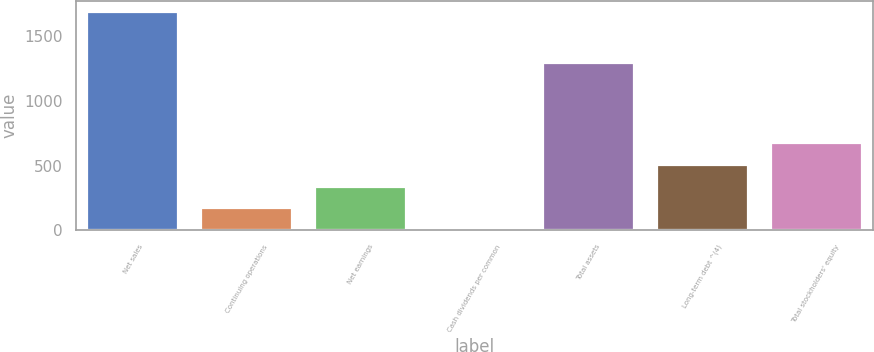Convert chart. <chart><loc_0><loc_0><loc_500><loc_500><bar_chart><fcel>Net sales<fcel>Continuing operations<fcel>Net earnings<fcel>Cash dividends per common<fcel>Total assets<fcel>Long-term debt ^(4)<fcel>Total stockholders' equity<nl><fcel>1689.2<fcel>169.5<fcel>338.36<fcel>0.64<fcel>1292.7<fcel>507.22<fcel>676.08<nl></chart> 